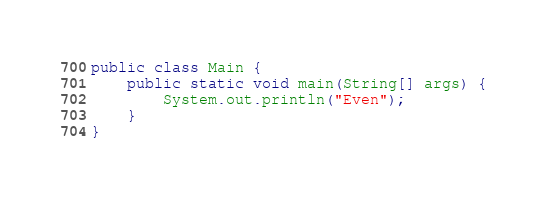Convert code to text. <code><loc_0><loc_0><loc_500><loc_500><_Java_>public class Main {
    public static void main(String[] args) {
        System.out.println("Even");
    }
}
</code> 